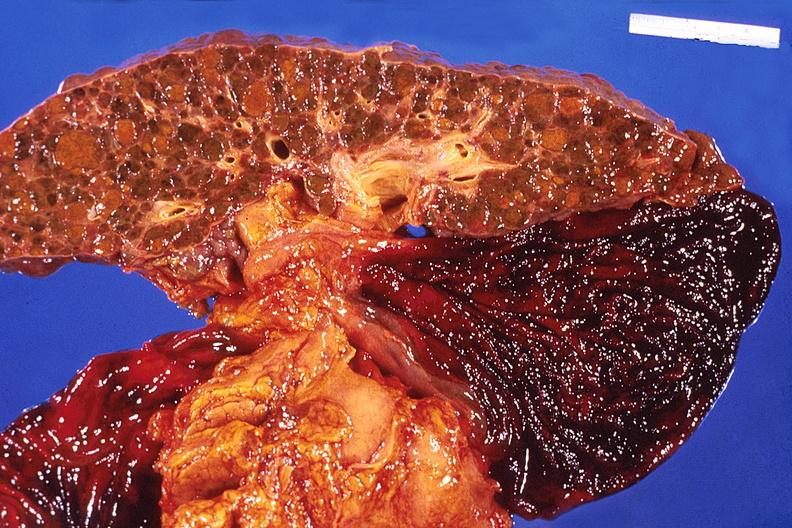what is present?
Answer the question using a single word or phrase. Hepatobiliary 